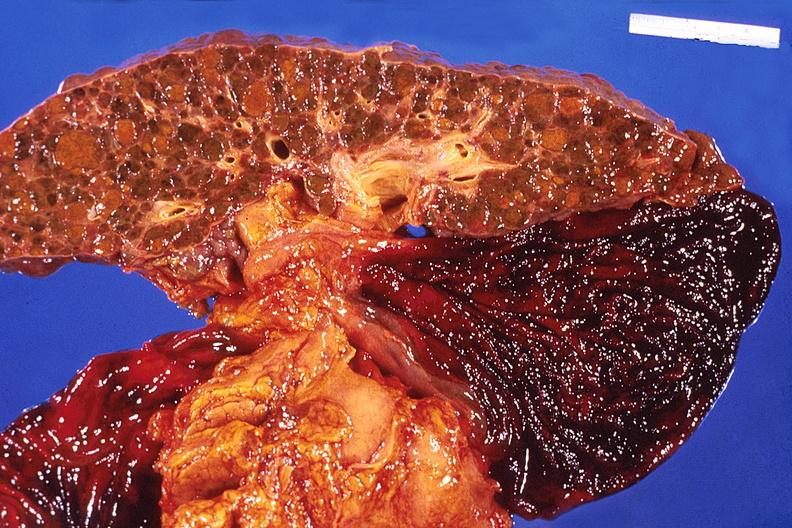what is present?
Answer the question using a single word or phrase. Hepatobiliary 